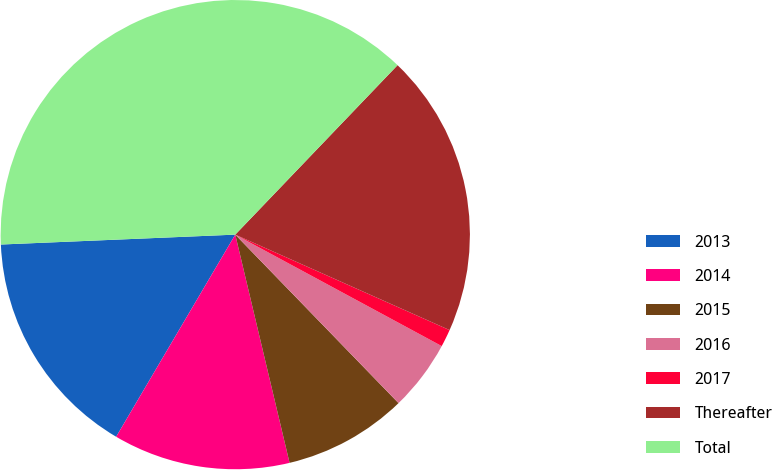Convert chart. <chart><loc_0><loc_0><loc_500><loc_500><pie_chart><fcel>2013<fcel>2014<fcel>2015<fcel>2016<fcel>2017<fcel>Thereafter<fcel>Total<nl><fcel>15.85%<fcel>12.19%<fcel>8.53%<fcel>4.87%<fcel>1.21%<fcel>19.51%<fcel>37.82%<nl></chart> 